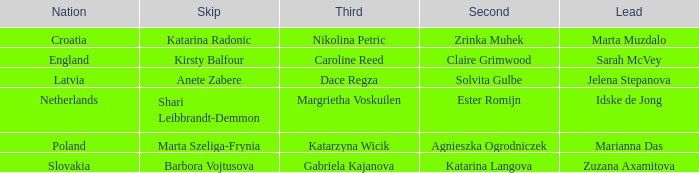What is the name of the third who has Barbora Vojtusova as Skip? Gabriela Kajanova. 